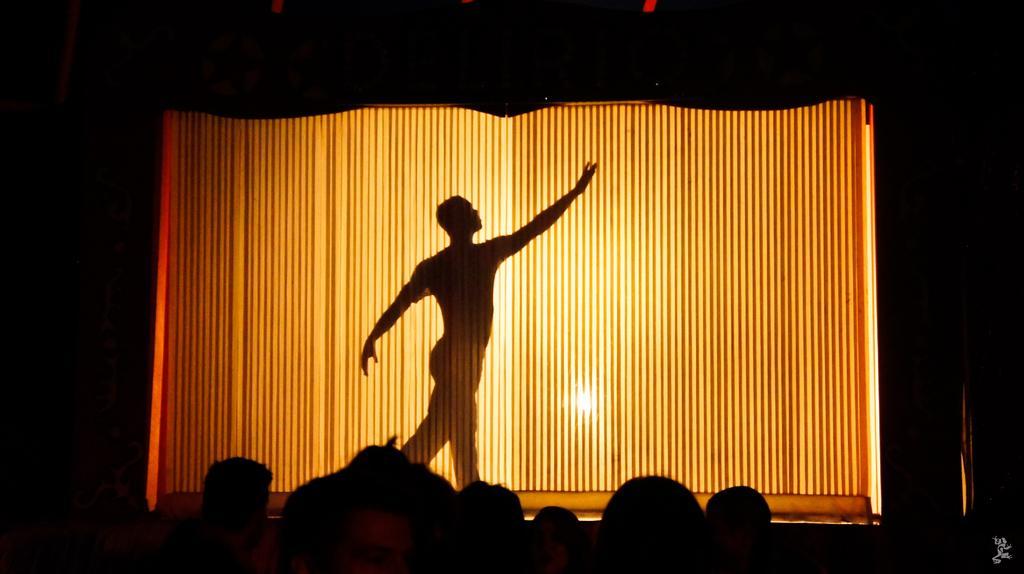In one or two sentences, can you explain what this image depicts? Here in the front we can see a curtain present on the stage over there and behind that curtain we can see a person dancing on the stage and we can also see a light beside him and in the front we can see people sitting and watching his performance. 